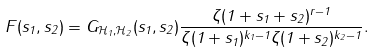Convert formula to latex. <formula><loc_0><loc_0><loc_500><loc_500>F ( s _ { 1 } , s _ { 2 } ) = G _ { \mathcal { H } _ { 1 } , \mathcal { H } _ { 2 } } ( s _ { 1 } , s _ { 2 } ) \frac { \zeta ( 1 + s _ { 1 } + s _ { 2 } ) ^ { r - 1 } } { \zeta ( 1 + s _ { 1 } ) ^ { k _ { 1 } - 1 } \zeta ( 1 + s _ { 2 } ) ^ { k _ { 2 } - 1 } } .</formula> 